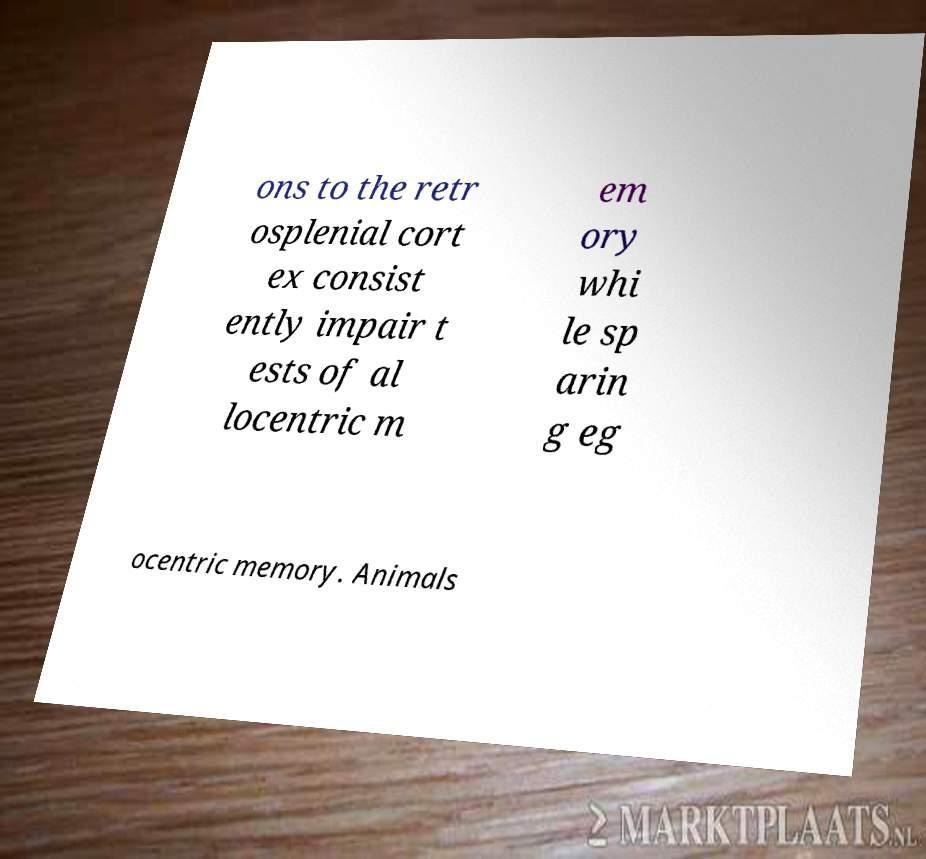I need the written content from this picture converted into text. Can you do that? ons to the retr osplenial cort ex consist ently impair t ests of al locentric m em ory whi le sp arin g eg ocentric memory. Animals 